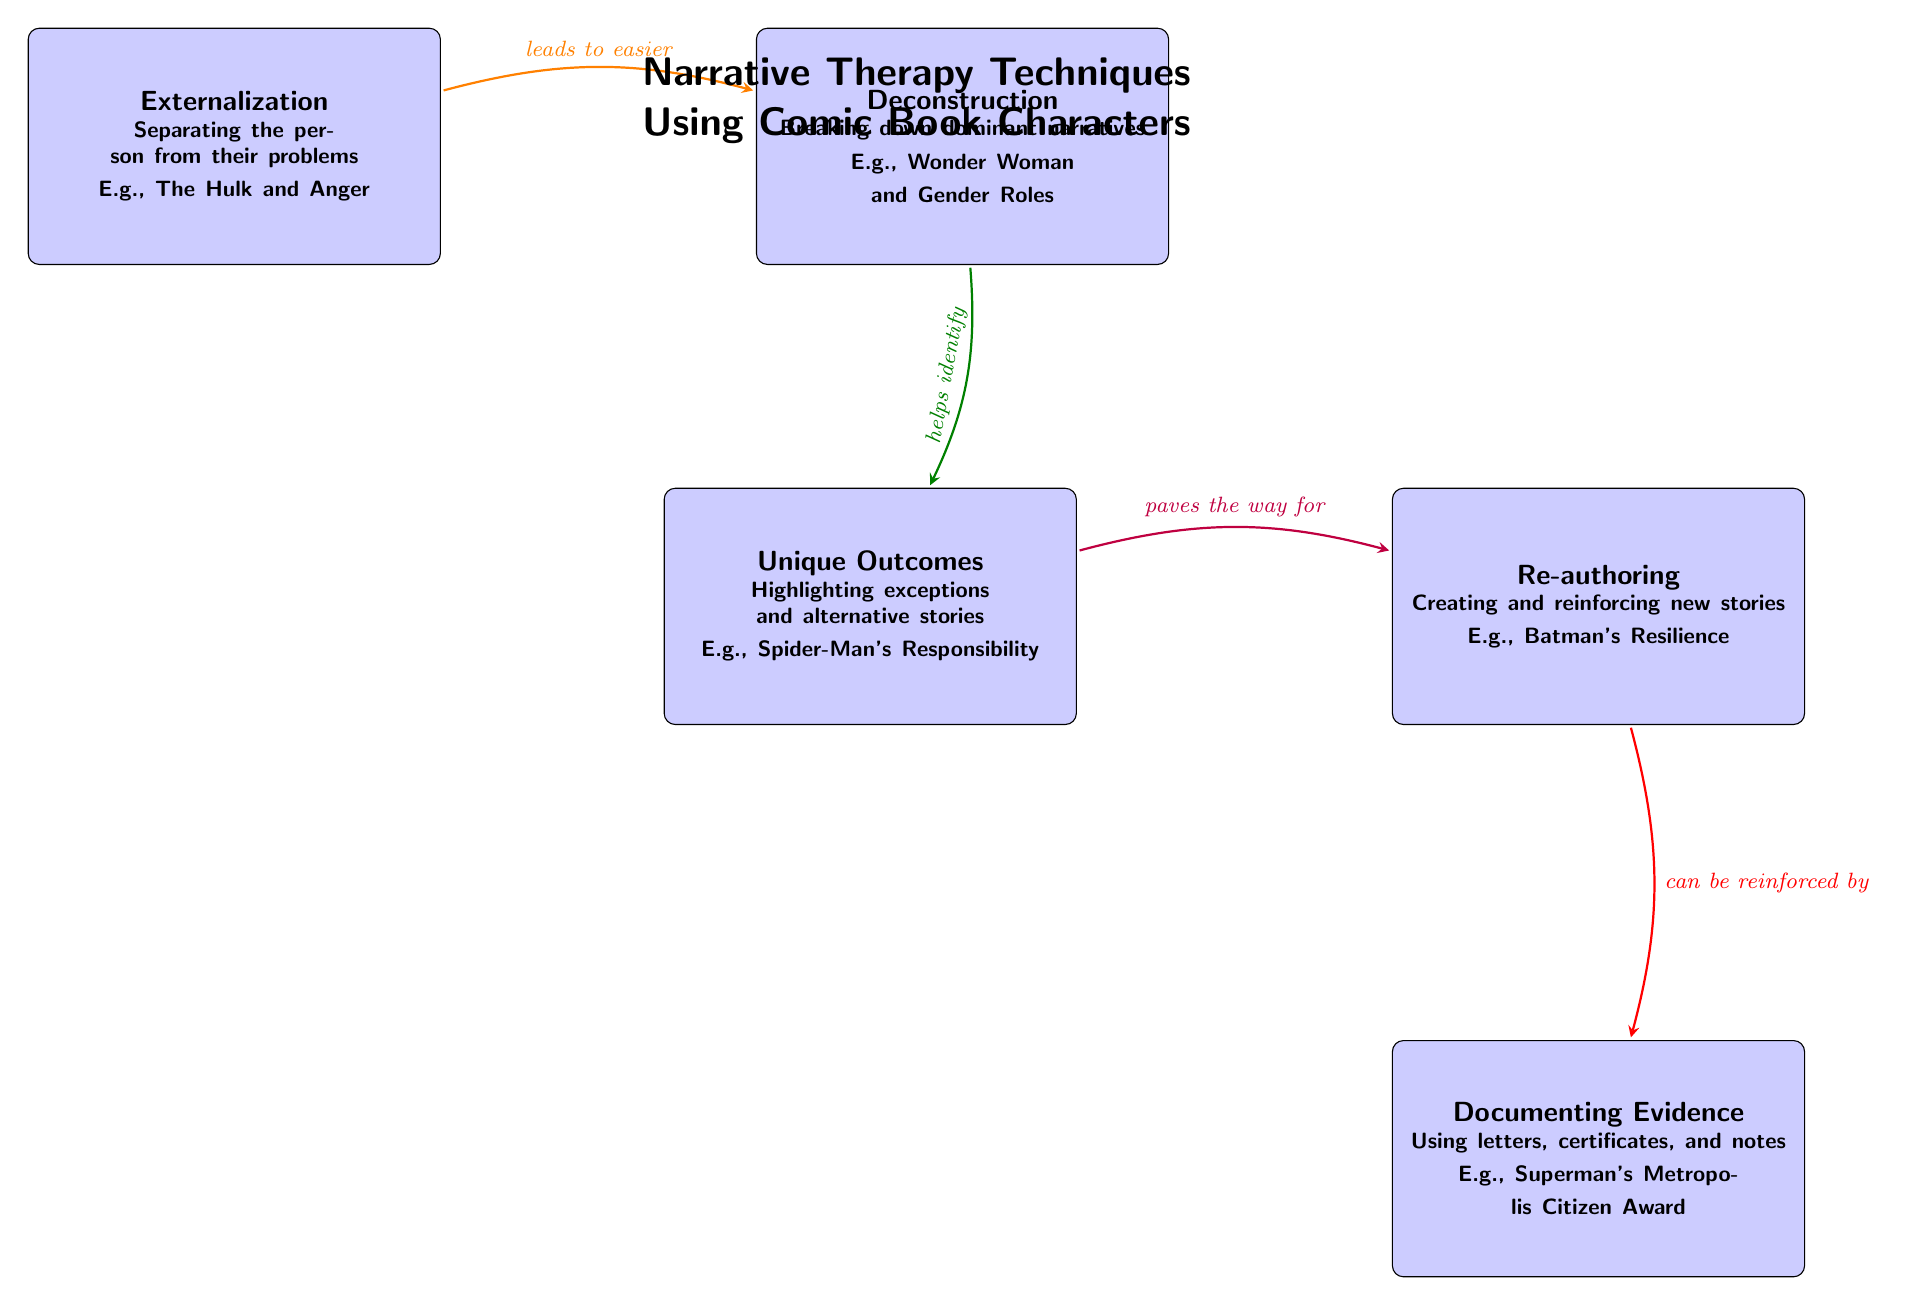What is the first technique listed in the diagram? The diagram lists "Externalization" as the first technique, which can be found at the top left of the diagram.
Answer: Externalization How many techniques are displayed in the diagram? There are five techniques shown in the diagram, which can be counted by looking at the rectangles representing each technique.
Answer: 5 What relationship does "Externalization" have with "Deconstruction"? The arrow from "Externalization" to "Deconstruction" indicates that "Externalization" leads to easier "Deconstruction", showing a directional flow from one node to the other.
Answer: leads to easier Which comic book character is associated with "Unique Outcomes"? The character associated with "Unique Outcomes" is "Spider-Man", as stated in the description within that node.
Answer: Spider-Man What's the main purpose of "Re-authoring"? The main purpose of "Re-authoring" is to create and reinforce new stories, as outlined in the text associated with that technique in the diagram.
Answer: Creating and reinforcing new stories What is directly below "Re-authoring"? The technique directly below "Re-authoring" is "Documenting Evidence", as seen in the layout of the nodes in the diagram.
Answer: Documenting Evidence How does "Unique Outcomes" relate to "Re-authoring"? "Unique Outcomes" paves the way for "Re-authoring", as indicated by the connecting arrow and the annotation placed above it.
Answer: paves the way for Which character is mentioned in the context of "Documenting Evidence"? The character mentioned in the context of "Documenting Evidence" is "Superman", as stated within the description of that technique.
Answer: Superman 